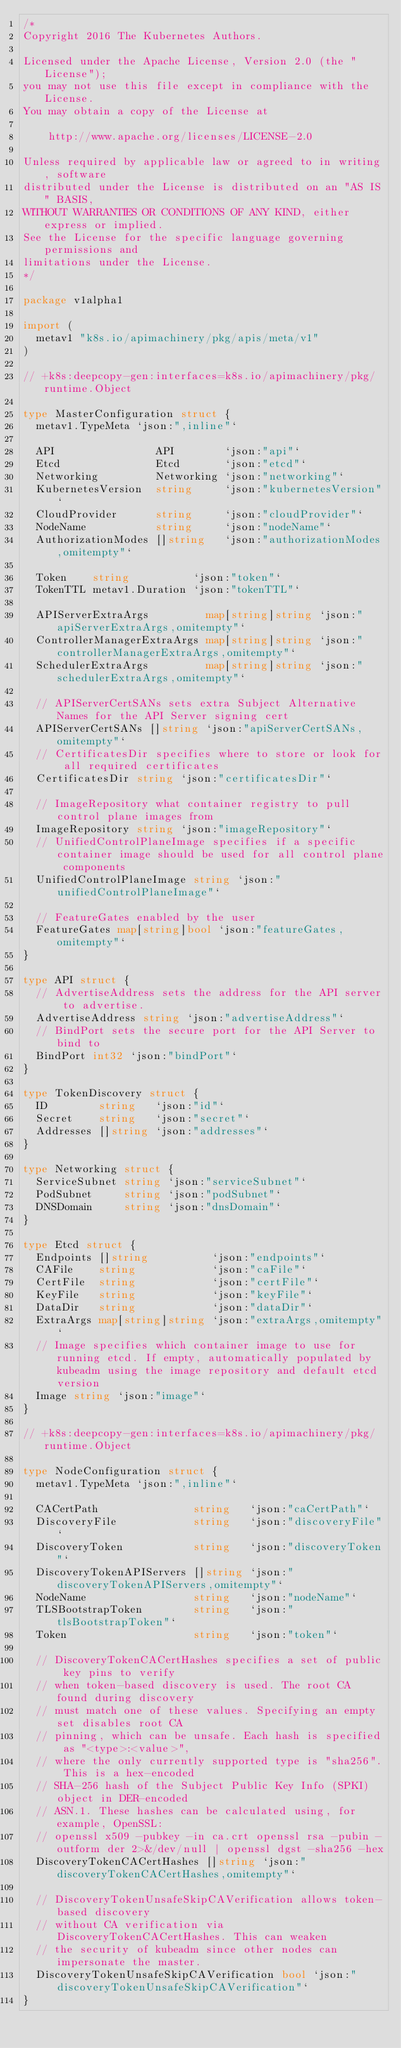Convert code to text. <code><loc_0><loc_0><loc_500><loc_500><_Go_>/*
Copyright 2016 The Kubernetes Authors.

Licensed under the Apache License, Version 2.0 (the "License");
you may not use this file except in compliance with the License.
You may obtain a copy of the License at

    http://www.apache.org/licenses/LICENSE-2.0

Unless required by applicable law or agreed to in writing, software
distributed under the License is distributed on an "AS IS" BASIS,
WITHOUT WARRANTIES OR CONDITIONS OF ANY KIND, either express or implied.
See the License for the specific language governing permissions and
limitations under the License.
*/

package v1alpha1

import (
	metav1 "k8s.io/apimachinery/pkg/apis/meta/v1"
)

// +k8s:deepcopy-gen:interfaces=k8s.io/apimachinery/pkg/runtime.Object

type MasterConfiguration struct {
	metav1.TypeMeta `json:",inline"`

	API                API        `json:"api"`
	Etcd               Etcd       `json:"etcd"`
	Networking         Networking `json:"networking"`
	KubernetesVersion  string     `json:"kubernetesVersion"`
	CloudProvider      string     `json:"cloudProvider"`
	NodeName           string     `json:"nodeName"`
	AuthorizationModes []string   `json:"authorizationModes,omitempty"`

	Token    string          `json:"token"`
	TokenTTL metav1.Duration `json:"tokenTTL"`

	APIServerExtraArgs         map[string]string `json:"apiServerExtraArgs,omitempty"`
	ControllerManagerExtraArgs map[string]string `json:"controllerManagerExtraArgs,omitempty"`
	SchedulerExtraArgs         map[string]string `json:"schedulerExtraArgs,omitempty"`

	// APIServerCertSANs sets extra Subject Alternative Names for the API Server signing cert
	APIServerCertSANs []string `json:"apiServerCertSANs,omitempty"`
	// CertificatesDir specifies where to store or look for all required certificates
	CertificatesDir string `json:"certificatesDir"`

	// ImageRepository what container registry to pull control plane images from
	ImageRepository string `json:"imageRepository"`
	// UnifiedControlPlaneImage specifies if a specific container image should be used for all control plane components
	UnifiedControlPlaneImage string `json:"unifiedControlPlaneImage"`

	// FeatureGates enabled by the user
	FeatureGates map[string]bool `json:"featureGates,omitempty"`
}

type API struct {
	// AdvertiseAddress sets the address for the API server to advertise.
	AdvertiseAddress string `json:"advertiseAddress"`
	// BindPort sets the secure port for the API Server to bind to
	BindPort int32 `json:"bindPort"`
}

type TokenDiscovery struct {
	ID        string   `json:"id"`
	Secret    string   `json:"secret"`
	Addresses []string `json:"addresses"`
}

type Networking struct {
	ServiceSubnet string `json:"serviceSubnet"`
	PodSubnet     string `json:"podSubnet"`
	DNSDomain     string `json:"dnsDomain"`
}

type Etcd struct {
	Endpoints []string          `json:"endpoints"`
	CAFile    string            `json:"caFile"`
	CertFile  string            `json:"certFile"`
	KeyFile   string            `json:"keyFile"`
	DataDir   string            `json:"dataDir"`
	ExtraArgs map[string]string `json:"extraArgs,omitempty"`
	// Image specifies which container image to use for running etcd. If empty, automatically populated by kubeadm using the image repository and default etcd version
	Image string `json:"image"`
}

// +k8s:deepcopy-gen:interfaces=k8s.io/apimachinery/pkg/runtime.Object

type NodeConfiguration struct {
	metav1.TypeMeta `json:",inline"`

	CACertPath               string   `json:"caCertPath"`
	DiscoveryFile            string   `json:"discoveryFile"`
	DiscoveryToken           string   `json:"discoveryToken"`
	DiscoveryTokenAPIServers []string `json:"discoveryTokenAPIServers,omitempty"`
	NodeName                 string   `json:"nodeName"`
	TLSBootstrapToken        string   `json:"tlsBootstrapToken"`
	Token                    string   `json:"token"`

	// DiscoveryTokenCACertHashes specifies a set of public key pins to verify
	// when token-based discovery is used. The root CA found during discovery
	// must match one of these values. Specifying an empty set disables root CA
	// pinning, which can be unsafe. Each hash is specified as "<type>:<value>",
	// where the only currently supported type is "sha256". This is a hex-encoded
	// SHA-256 hash of the Subject Public Key Info (SPKI) object in DER-encoded
	// ASN.1. These hashes can be calculated using, for example, OpenSSL:
	// openssl x509 -pubkey -in ca.crt openssl rsa -pubin -outform der 2>&/dev/null | openssl dgst -sha256 -hex
	DiscoveryTokenCACertHashes []string `json:"discoveryTokenCACertHashes,omitempty"`

	// DiscoveryTokenUnsafeSkipCAVerification allows token-based discovery
	// without CA verification via DiscoveryTokenCACertHashes. This can weaken
	// the security of kubeadm since other nodes can impersonate the master.
	DiscoveryTokenUnsafeSkipCAVerification bool `json:"discoveryTokenUnsafeSkipCAVerification"`
}
</code> 